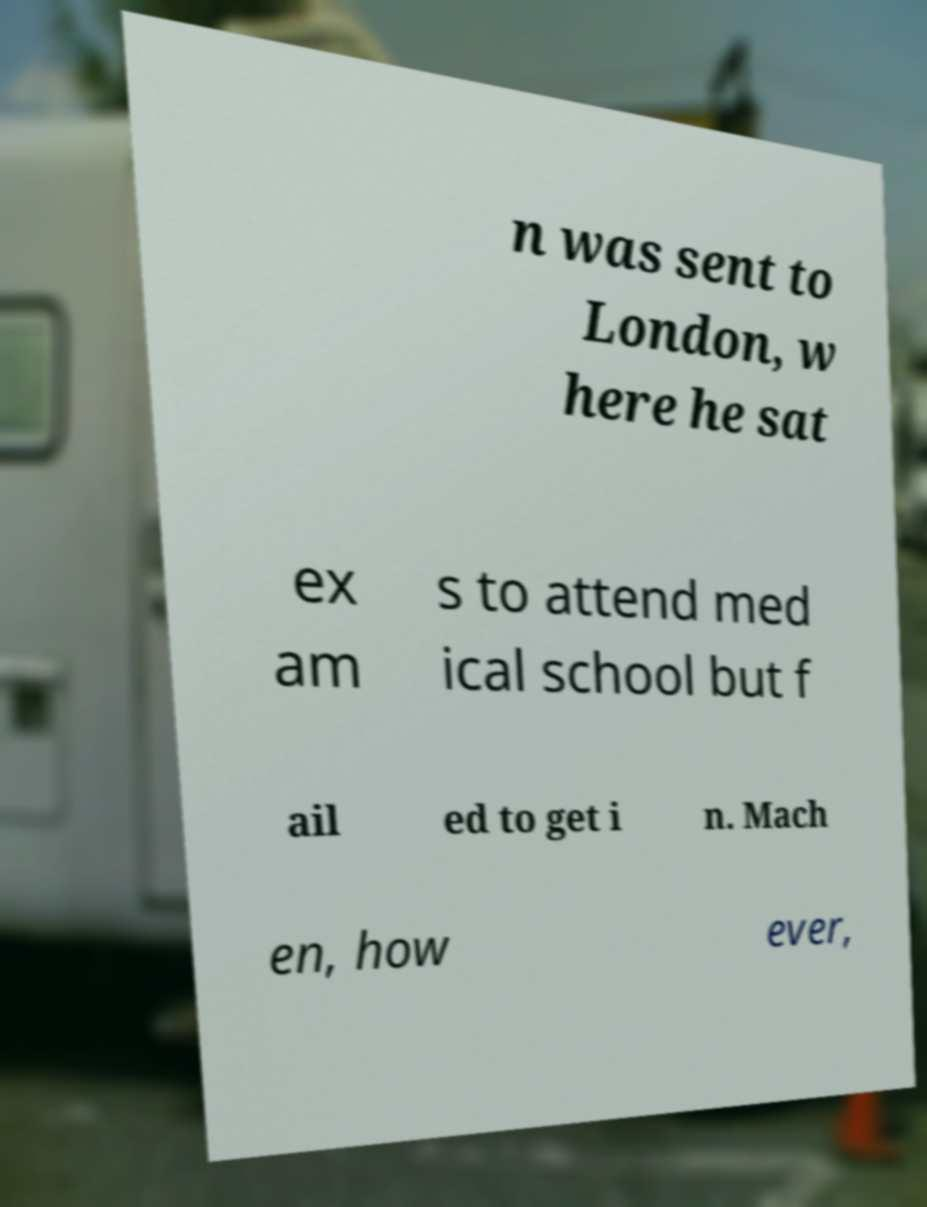Please identify and transcribe the text found in this image. n was sent to London, w here he sat ex am s to attend med ical school but f ail ed to get i n. Mach en, how ever, 